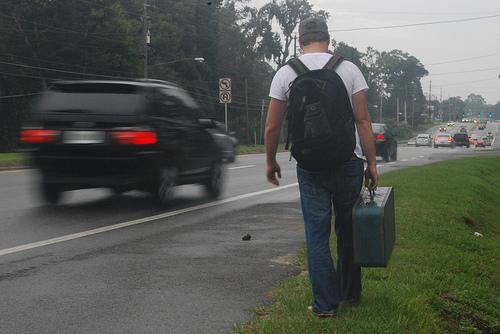Provide an estimate of how many objects are described in the image. There are approximately 18 objects described in the image, including the man, suitcase, backpack, cap, cars, road sign, trees, and grassy area. How many cars can be seen in the image, and do any of them appear to be a specific make or model? There are cars in the background, including a black SUV, a silver vehicle, and possibly a Toyota Prius, but the exact number is unclear. Describe the landscape and environment where the man is walking. The man is walking on a grassy area alongside a highway with trees and road signs in the background. Based on the image, infer the possible emotions or feelings the man might be experiencing. The man could be feeling tired, determined, or focused, as he walks on the grassy area while carrying his suitcase and wearing a backpack. Can you determine if the vehicles on the highway are moving or stationary based on the image? Some vehicles appear to be in motion, like a black SUV and a silver vehicle, while others like the black car with brake lights on or a vehicle stopped in traffic seem to be stationary. Comment on the man's attire, including the color and type of his shirt and pants. The man is wearing a white t-shirt with short sleeves and blue jeans. If we wanted to improve the image quality, what changes could be made to the composition or focus? To improve image quality, we might improve lighting or contrast, increase the focus on the main subject (the man), and possibly reduce background noise or clutter to bring better attention to the man and his actions. Identify the color of the suitcase that the man is carrying. The man is carrying a green suitcase. State the color of the backpack and the material it's likely made of. The backpack is black in color and is likely made of fabric or nylon material. What kind of hat is the man wearing in the image? The man is wearing a cap on his head. 